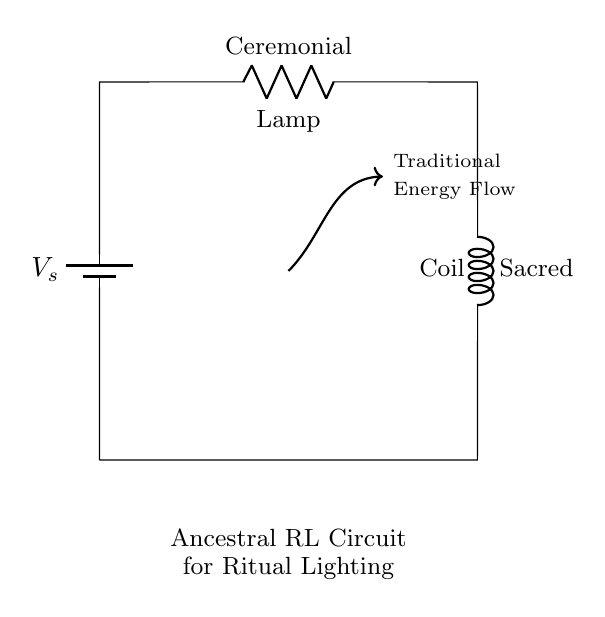What is the voltage source labeled as? The voltage source is labeled as "V_s", which typically represents the supply voltage in a circuit diagram.
Answer: V_s What component is represented by the labeled "R" in the circuit? The labeled "R" represents the ceremonial lamp, indicating its role as a resistive element that converts electrical energy into light.
Answer: Ceremonial Lamp What component is represented by the labeled "L" in the circuit? The component labeled "L" indicates the sacred coil, which acts as an inductive element in the circuit, storing energy in a magnetic field when current passes through it.
Answer: Sacred Coil How do the resistor and inductor connect in this circuit? The resistor (ceremonial lamp) and inductor (sacred coil) are connected in series, which means the current flows through the resistor and then through the inductor sequentially.
Answer: In series What is the primary function of this RL circuit? The primary function of this RL circuit is to power traditional ceremonial lighting displays by controlling the flow of electrical energy through the components.
Answer: Power lighting What must happen for the lamp to emit light in this circuit? For the lamp to emit light, current must flow through the circuit, which is established by the voltage source overcoming the resistance of the lamp and the inductor's reactance.
Answer: Current must flow How does inductance affect the current in this circuit? Inductance in this circuit introduces a delay in the current flow due to its property of opposing sudden changes in current, resulting in gradual increases in load.
Answer: Delays current flow 